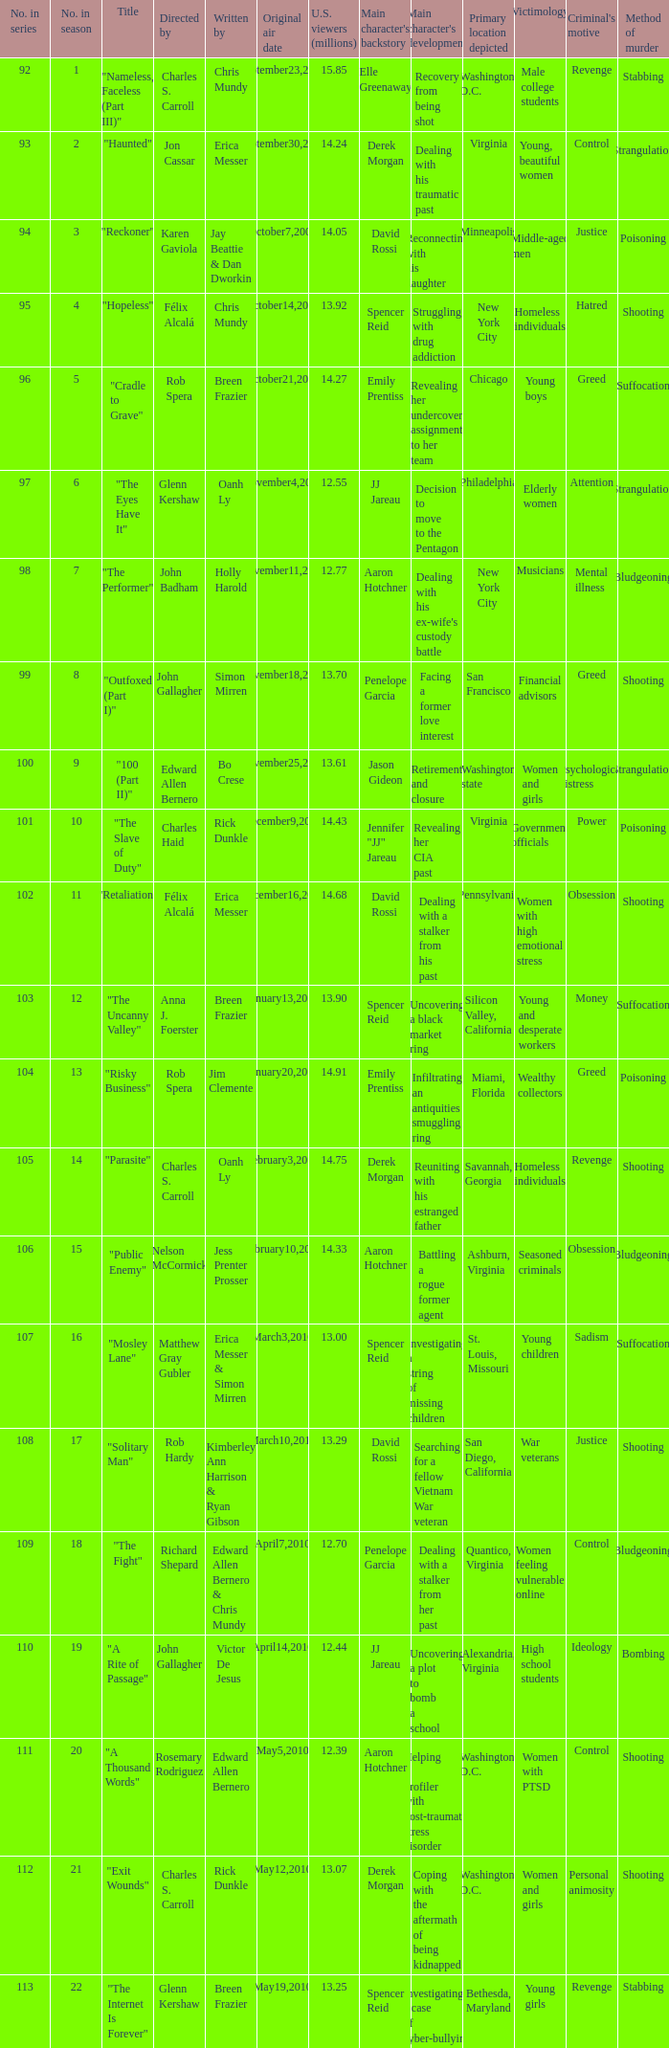Who wrote episode number 109 in the series? Edward Allen Bernero & Chris Mundy. 